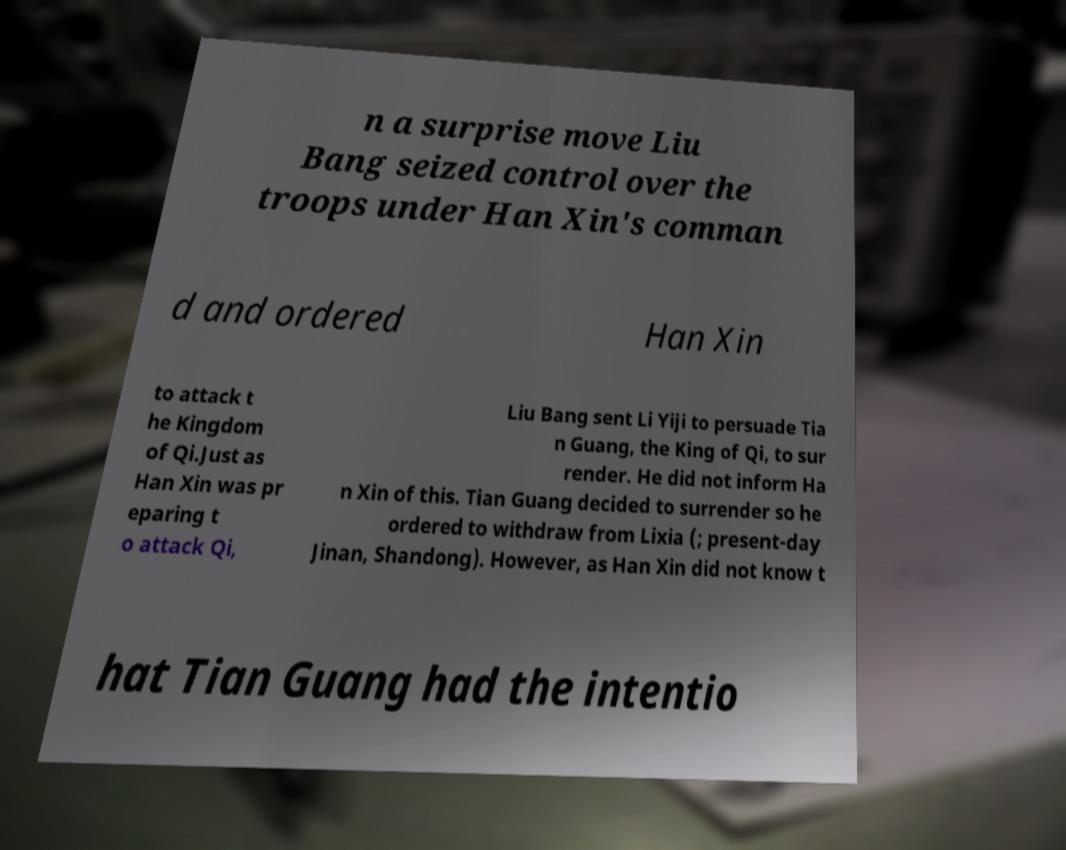Please identify and transcribe the text found in this image. n a surprise move Liu Bang seized control over the troops under Han Xin's comman d and ordered Han Xin to attack t he Kingdom of Qi.Just as Han Xin was pr eparing t o attack Qi, Liu Bang sent Li Yiji to persuade Tia n Guang, the King of Qi, to sur render. He did not inform Ha n Xin of this. Tian Guang decided to surrender so he ordered to withdraw from Lixia (; present-day Jinan, Shandong). However, as Han Xin did not know t hat Tian Guang had the intentio 